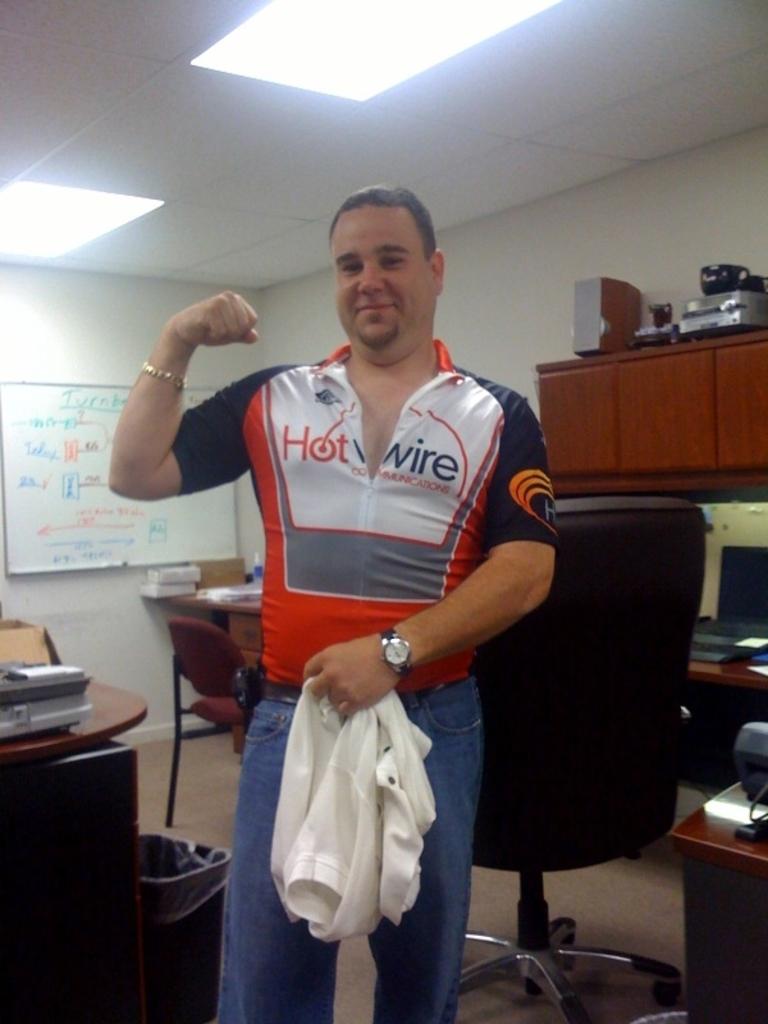What is the word at the top of the whiteboard?
Your answer should be compact. Unanswerable. 